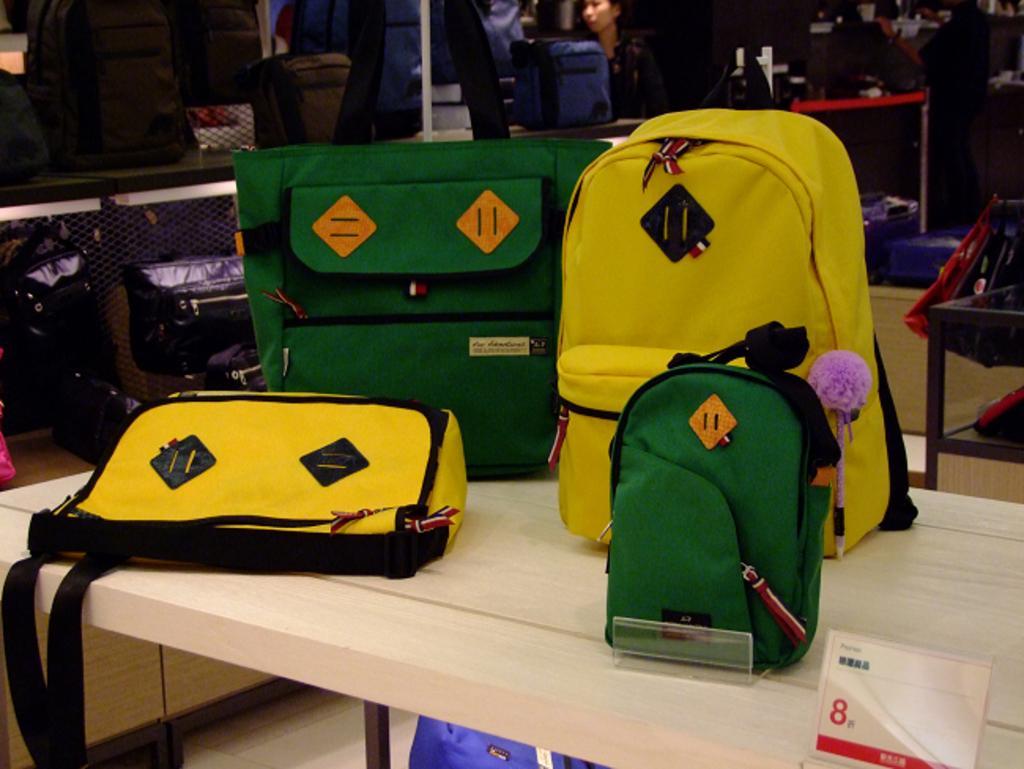Can you describe this image briefly? This image consists of a table and bags on it. Behind that there is a rack in that rack there are so many bags and in the bottom right corner there is price board. 